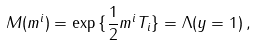Convert formula to latex. <formula><loc_0><loc_0><loc_500><loc_500>M ( m ^ { i } ) = \exp { \{ { \frac { 1 } { 2 } } m ^ { i } T _ { i } \} } = \Lambda ( y = 1 ) \, ,</formula> 